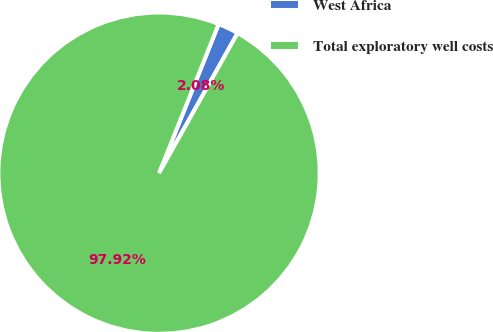Convert chart. <chart><loc_0><loc_0><loc_500><loc_500><pie_chart><fcel>West Africa<fcel>Total exploratory well costs<nl><fcel>2.08%<fcel>97.92%<nl></chart> 